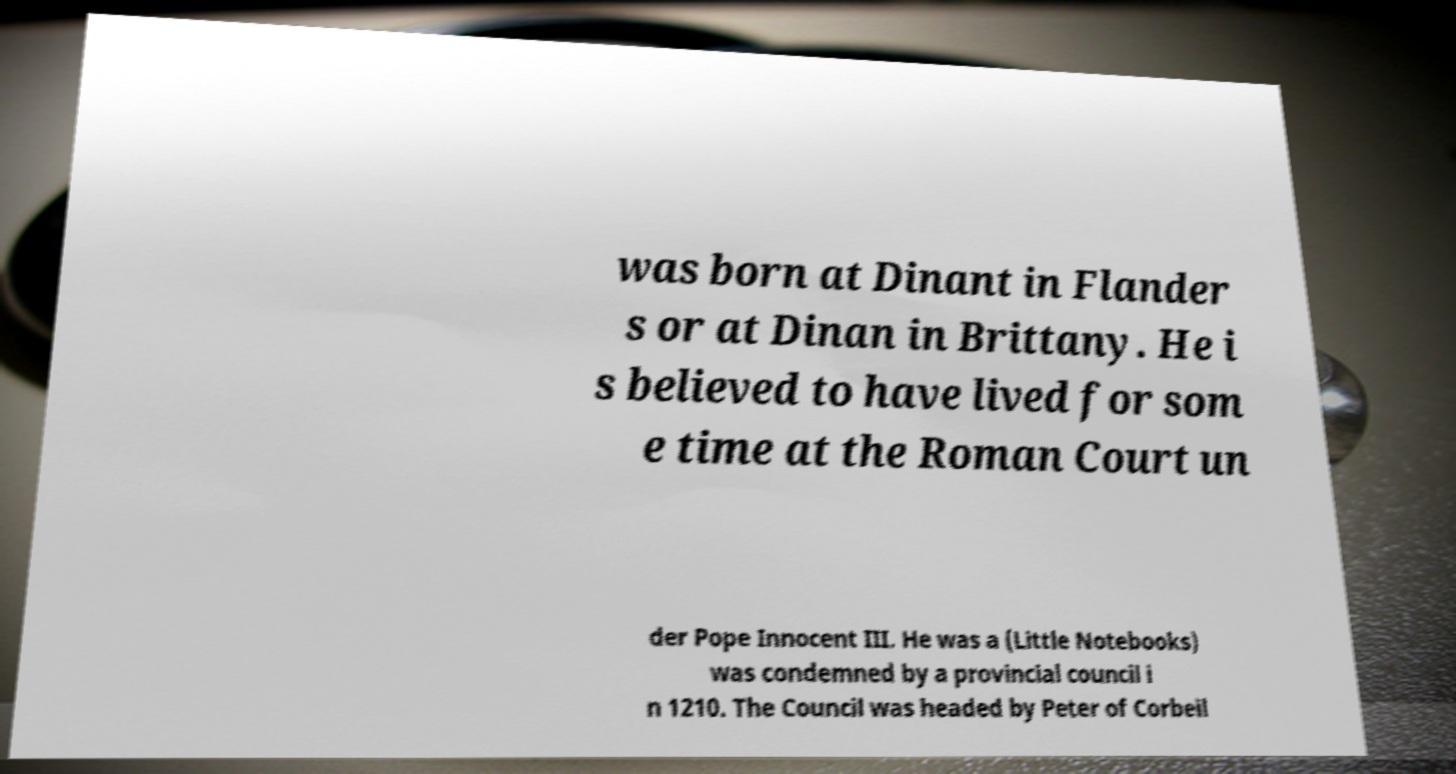Could you extract and type out the text from this image? was born at Dinant in Flander s or at Dinan in Brittany. He i s believed to have lived for som e time at the Roman Court un der Pope Innocent III. He was a (Little Notebooks) was condemned by a provincial council i n 1210. The Council was headed by Peter of Corbeil 